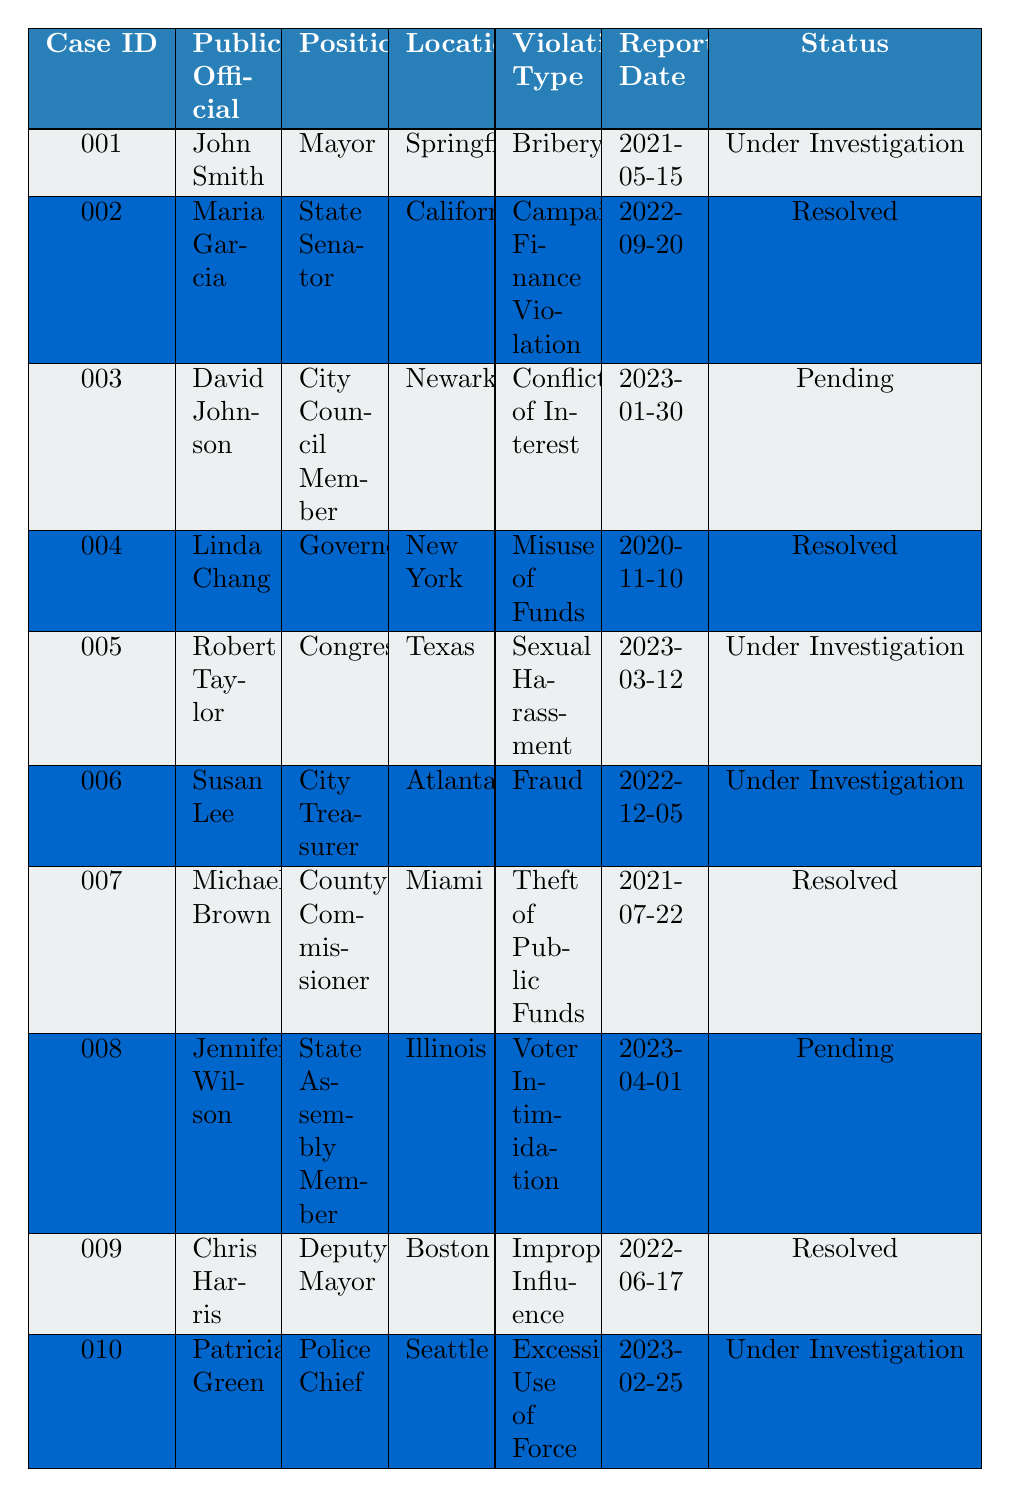What type of violation is associated with John Smith? John Smith is listed in the table, and by checking the "Violation Type" column, we see that it states "Bribery."
Answer: Bribery How many cases are currently under investigation? By reviewing the "Status" column, the cases with the status "Under Investigation" are John Smith, Robert Taylor, Susan Lee, and Patricia Green. Counting these, we find there are 4 cases.
Answer: 4 Is there any case involving sexual harassment? Looking through the "Violation Type" column, I find that Robert Taylor's case is labeled as "Sexual Harassment," confirming that such a case exists.
Answer: Yes Which public official has the status "Pending" and what is the violation type? From the table, I see David Johnson and Jennifer Wilson are labeled with the status "Pending." David Johnson's violation type is "Conflict of Interest," while Jennifer Wilson's is "Voter Intimidation."
Answer: David Johnson: Conflict of Interest; Jennifer Wilson: Voter Intimidation What is the most recent reported date of an ethical violation case? I look through the "Reported Date" column and identify the latest date listed, which is 2023-04-01 for the case involving Jennifer Wilson.
Answer: 2023-04-01 How many resolved cases are related to misuse of funds? I check the "Violation Type" for resolved cases, finding only Linda Chang's case identified as "Misuse of Funds." Since there is only one instance, the count is one.
Answer: 1 Is there any resolved case involving a mayor? I look for cases where the "Public Official" is a mayor and check the corresponding "Status." Here, John Smith is a mayor but is under investigation, with no resolved case matching that position.
Answer: No What is the position of the public official associated with the violation type "Fraud"? I locate the entry labeled "Fraud" in the "Violation Type" column, which belongs to Susan Lee, listed as the "City Treasurer."
Answer: City Treasurer How many different violation types are present in the table? I review the unique values in the "Violation Type" column, finding the following distinct types: Bribery, Campaign Finance Violation, Conflict of Interest, Misuse of Funds, Sexual Harassment, Fraud, Theft of Public Funds, Voter Intimidation, Improper Influence, Excessive Use of Force. Counting these reveals there are 10 different violations.
Answer: 10 